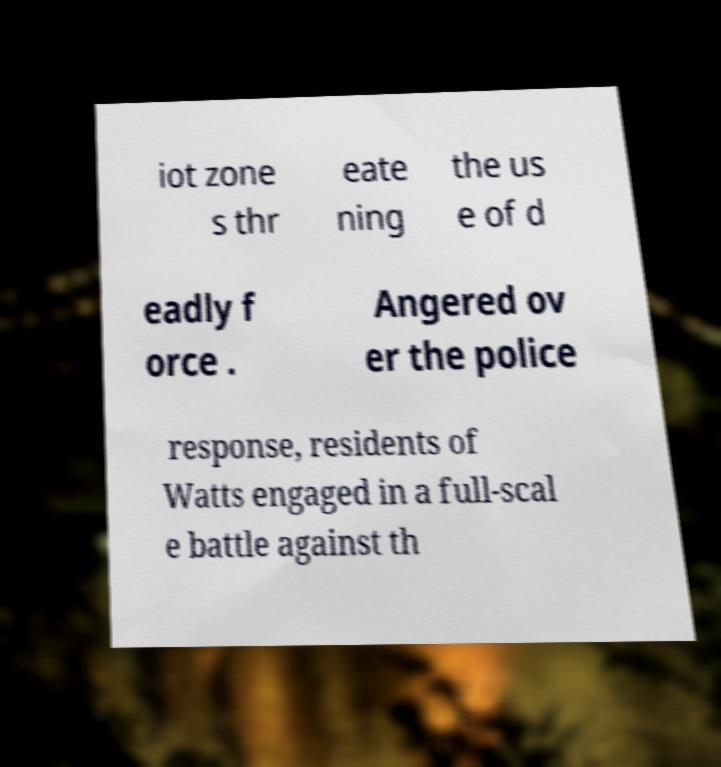Please read and relay the text visible in this image. What does it say? iot zone s thr eate ning the us e of d eadly f orce . Angered ov er the police response, residents of Watts engaged in a full-scal e battle against th 